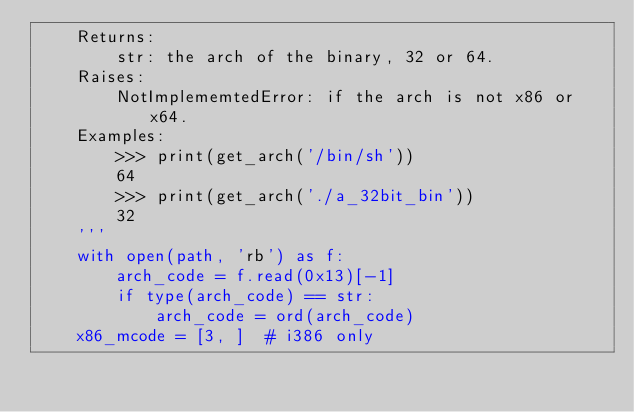<code> <loc_0><loc_0><loc_500><loc_500><_Python_>    Returns:
        str: the arch of the binary, 32 or 64.
    Raises:
        NotImplememtedError: if the arch is not x86 or x64.
    Examples:
        >>> print(get_arch('/bin/sh'))
        64
        >>> print(get_arch('./a_32bit_bin'))
        32
    '''
    with open(path, 'rb') as f:
        arch_code = f.read(0x13)[-1]
        if type(arch_code) == str:
            arch_code = ord(arch_code)
    x86_mcode = [3, ]  # i386 only</code> 